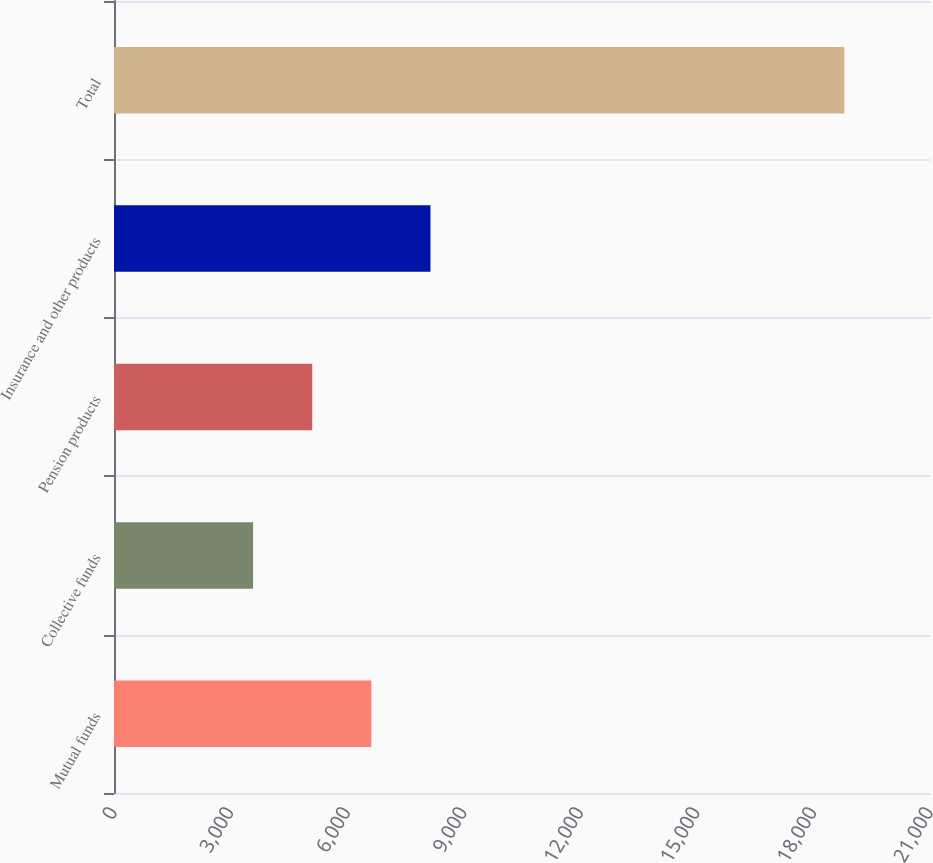Convert chart to OTSL. <chart><loc_0><loc_0><loc_500><loc_500><bar_chart><fcel>Mutual funds<fcel>Collective funds<fcel>Pension products<fcel>Insurance and other products<fcel>Total<nl><fcel>6623<fcel>3580<fcel>5101.5<fcel>8144.5<fcel>18795<nl></chart> 